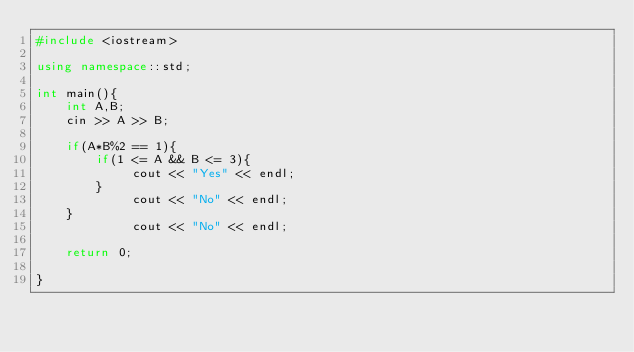Convert code to text. <code><loc_0><loc_0><loc_500><loc_500><_C++_>#include <iostream>

using namespace::std;

int main(){
    int A,B;
    cin >> A >> B;

    if(A*B%2 == 1){
        if(1 <= A && B <= 3){
             cout << "Yes" << endl;
        }
             cout << "No" << endl;
    }
             cout << "No" << endl;

    return 0;

}</code> 